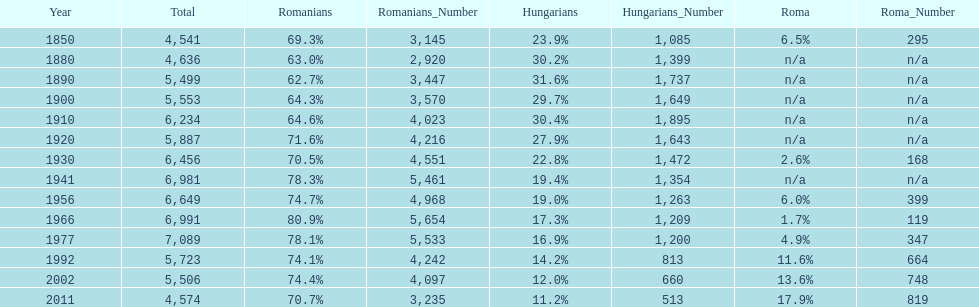What year had the next highest percentage for roma after 2011? 2002. 